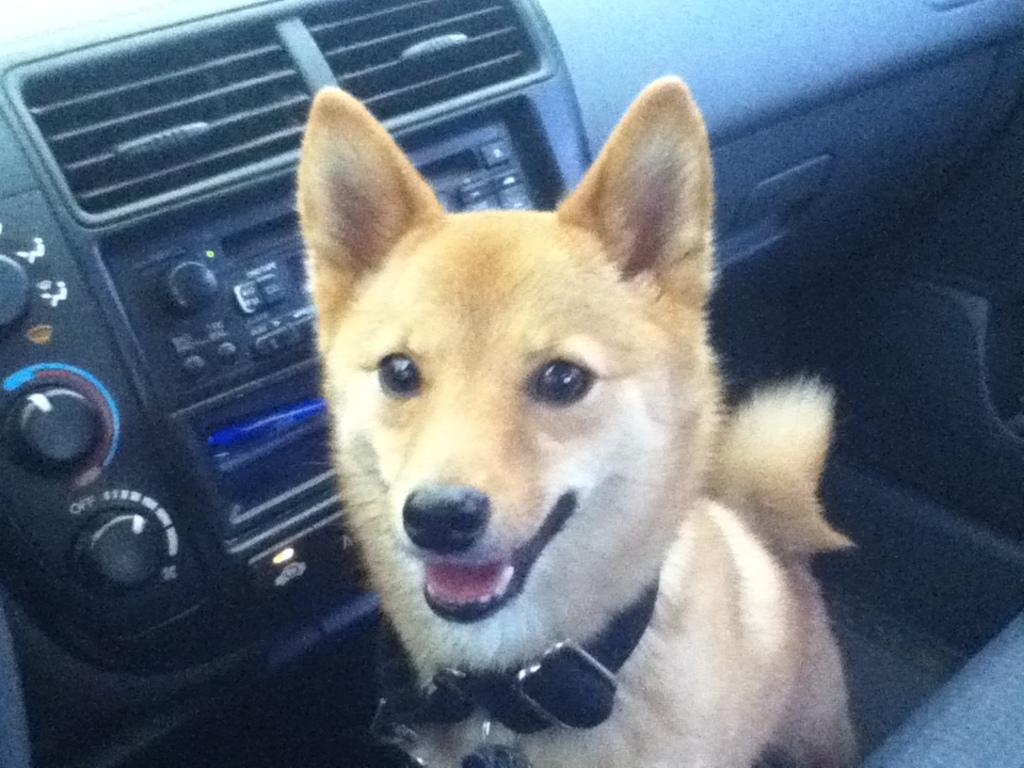What type of animal is inside the car in the image? There is a dog inside the car. What can be found in the car besides the dog? There is a music system in the car. Can you describe the seating arrangement in the car? There is a seat on the right side bottom of the car. Where is the waste disposal system located in the car? There is no mention of a waste disposal system in the image, so it cannot be located. 